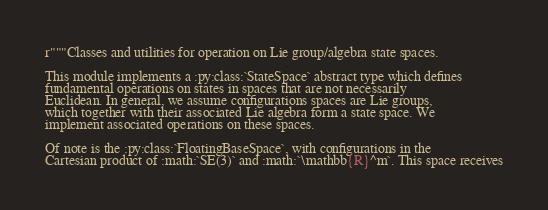Convert code to text. <code><loc_0><loc_0><loc_500><loc_500><_Python_>r"""Classes and utilities for operation on Lie group/algebra state spaces.

This module implements a :py:class:`StateSpace` abstract type which defines
fundamental operations on states in spaces that are not necessarily
Euclidean. In general, we assume configurations spaces are Lie groups,
which together with their associated Lie algebra form a state space. We
implement associated operations on these spaces.

Of note is the :py:class:`FloatingBaseSpace`, with configurations in the
Cartesian product of :math:`SE(3)` and :math:`\mathbb{R}^m`. This space receives</code> 